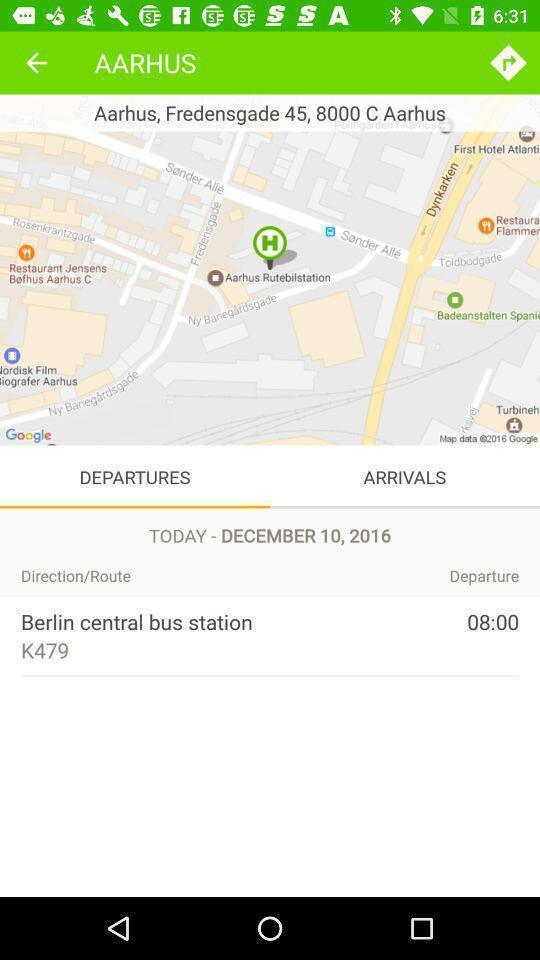Tell me about the visual elements in this screen capture. Screen showing departures page of a travel app. 